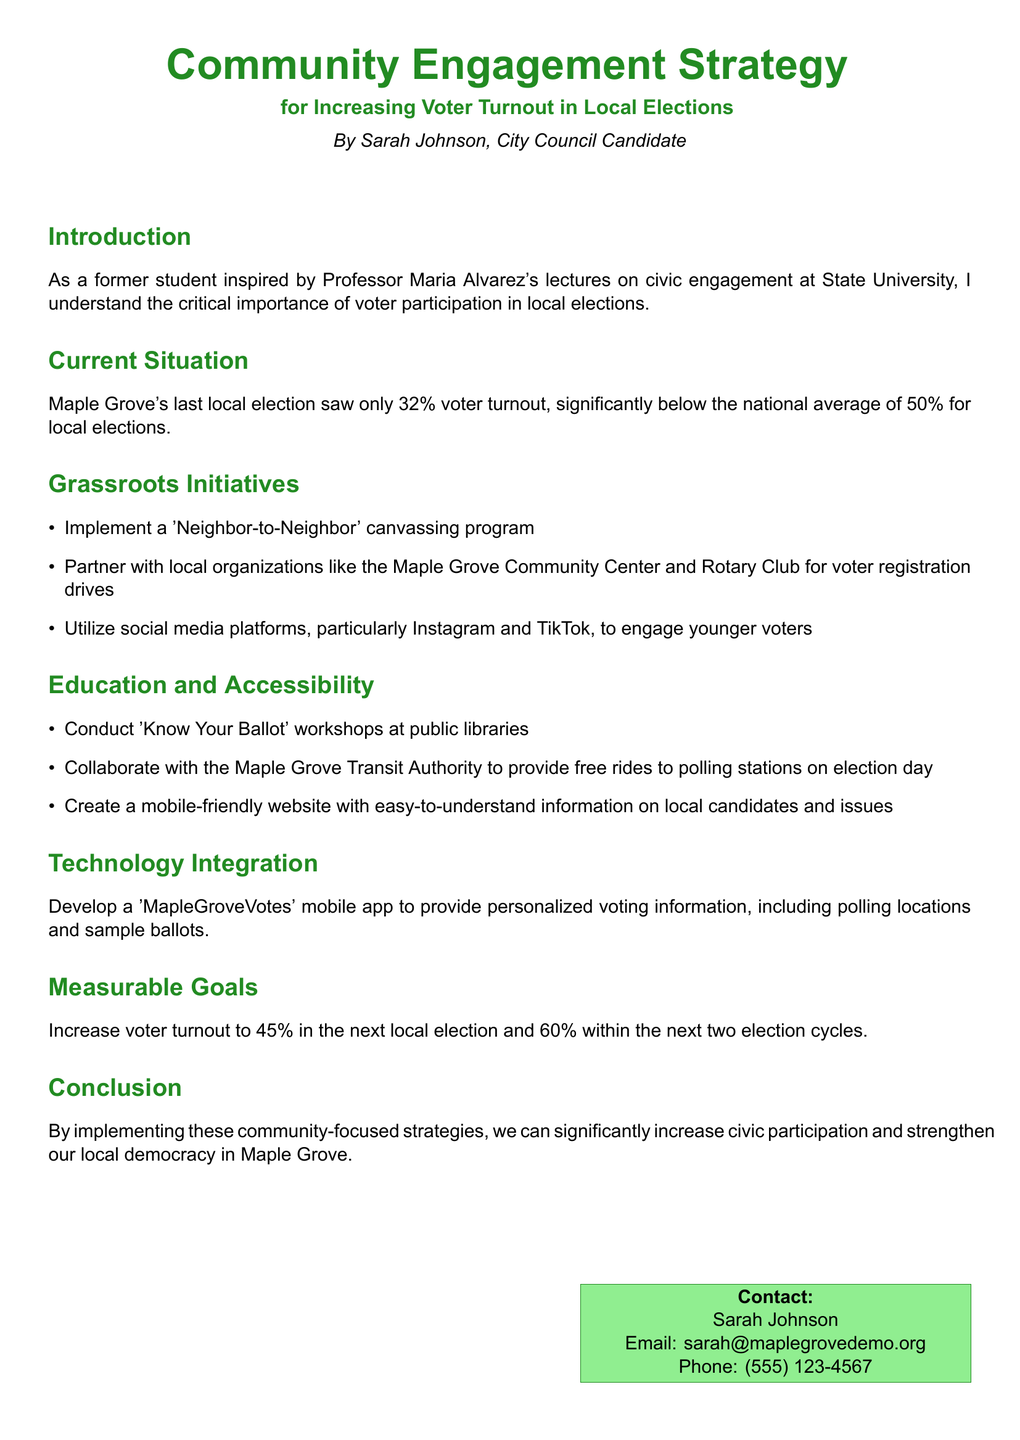What was the voter turnout in Maple Grove's last local election? The document states that Maple Grove's last local election saw only 32% voter turnout.
Answer: 32% What is the target voter turnout for the next local election? The document specifies that the goal is to increase voter turnout to 45% in the next local election.
Answer: 45% Which social media platforms are mentioned for engaging younger voters? The document lists Instagram and TikTok as platforms to engage younger voters.
Answer: Instagram and TikTok Who is the author of the community engagement strategy? The document identifies Sarah Johnson as the author of the strategy.
Answer: Sarah Johnson What is one method proposed for increasing accessibility to polling stations? The document mentions collaborating with the Maple Grove Transit Authority to provide free rides to polling stations.
Answer: Free rides How many election cycles does the strategy aim to achieve a 60% voter turnout? The document states the goal is to reach a 60% turnout within the next two election cycles.
Answer: Two election cycles What type of workshops are proposed to educate voters about the ballot? The document calls for conducting 'Know Your Ballot' workshops.
Answer: 'Know Your Ballot' workshops What is the name of the proposed mobile app? The document introduces a mobile app named 'MapleGroveVotes'.
Answer: MapleGroveVotes 